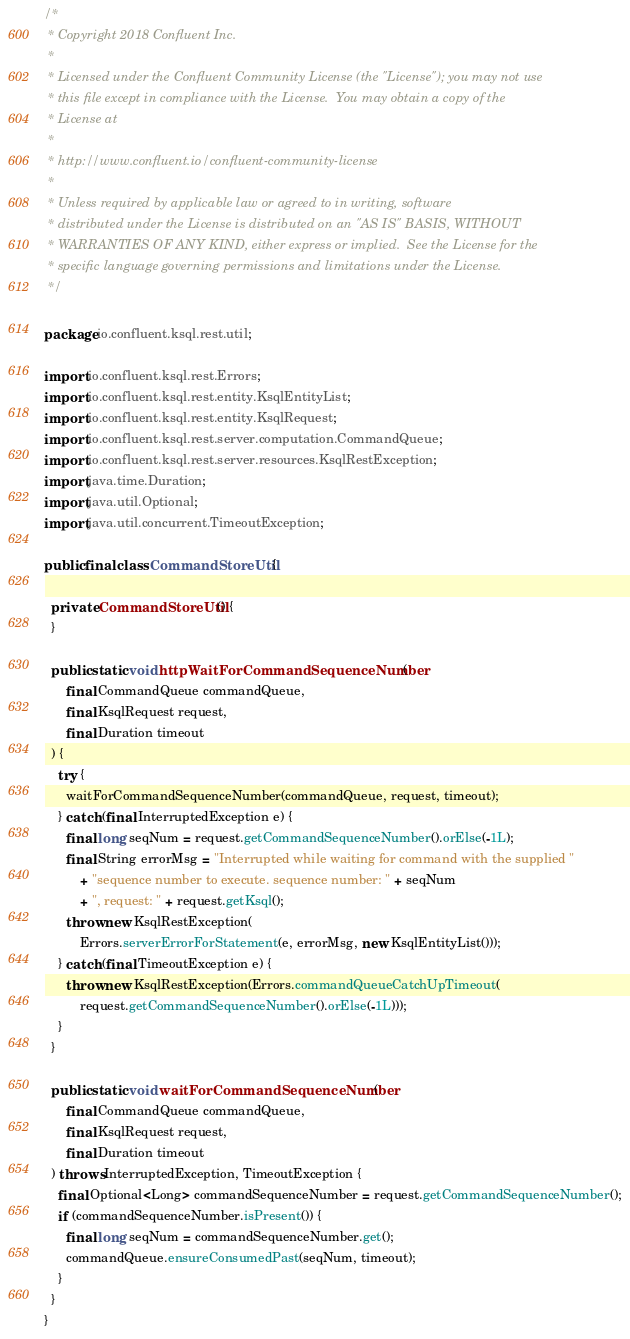<code> <loc_0><loc_0><loc_500><loc_500><_Java_>/*
 * Copyright 2018 Confluent Inc.
 *
 * Licensed under the Confluent Community License (the "License"); you may not use
 * this file except in compliance with the License.  You may obtain a copy of the
 * License at
 *
 * http://www.confluent.io/confluent-community-license
 *
 * Unless required by applicable law or agreed to in writing, software
 * distributed under the License is distributed on an "AS IS" BASIS, WITHOUT
 * WARRANTIES OF ANY KIND, either express or implied.  See the License for the
 * specific language governing permissions and limitations under the License.
 */

package io.confluent.ksql.rest.util;

import io.confluent.ksql.rest.Errors;
import io.confluent.ksql.rest.entity.KsqlEntityList;
import io.confluent.ksql.rest.entity.KsqlRequest;
import io.confluent.ksql.rest.server.computation.CommandQueue;
import io.confluent.ksql.rest.server.resources.KsqlRestException;
import java.time.Duration;
import java.util.Optional;
import java.util.concurrent.TimeoutException;

public final class CommandStoreUtil {

  private CommandStoreUtil() {
  }

  public static void httpWaitForCommandSequenceNumber(
      final CommandQueue commandQueue,
      final KsqlRequest request,
      final Duration timeout
  ) {
    try {
      waitForCommandSequenceNumber(commandQueue, request, timeout);
    } catch (final InterruptedException e) {
      final long seqNum = request.getCommandSequenceNumber().orElse(-1L);
      final String errorMsg = "Interrupted while waiting for command with the supplied "
          + "sequence number to execute. sequence number: " + seqNum
          + ", request: " + request.getKsql();
      throw new KsqlRestException(
          Errors.serverErrorForStatement(e, errorMsg, new KsqlEntityList()));
    } catch (final TimeoutException e) {
      throw new KsqlRestException(Errors.commandQueueCatchUpTimeout(
          request.getCommandSequenceNumber().orElse(-1L)));
    }
  }

  public static void waitForCommandSequenceNumber(
      final CommandQueue commandQueue,
      final KsqlRequest request,
      final Duration timeout
  ) throws InterruptedException, TimeoutException {
    final Optional<Long> commandSequenceNumber = request.getCommandSequenceNumber();
    if (commandSequenceNumber.isPresent()) {
      final long seqNum = commandSequenceNumber.get();
      commandQueue.ensureConsumedPast(seqNum, timeout);
    }
  }
}
</code> 